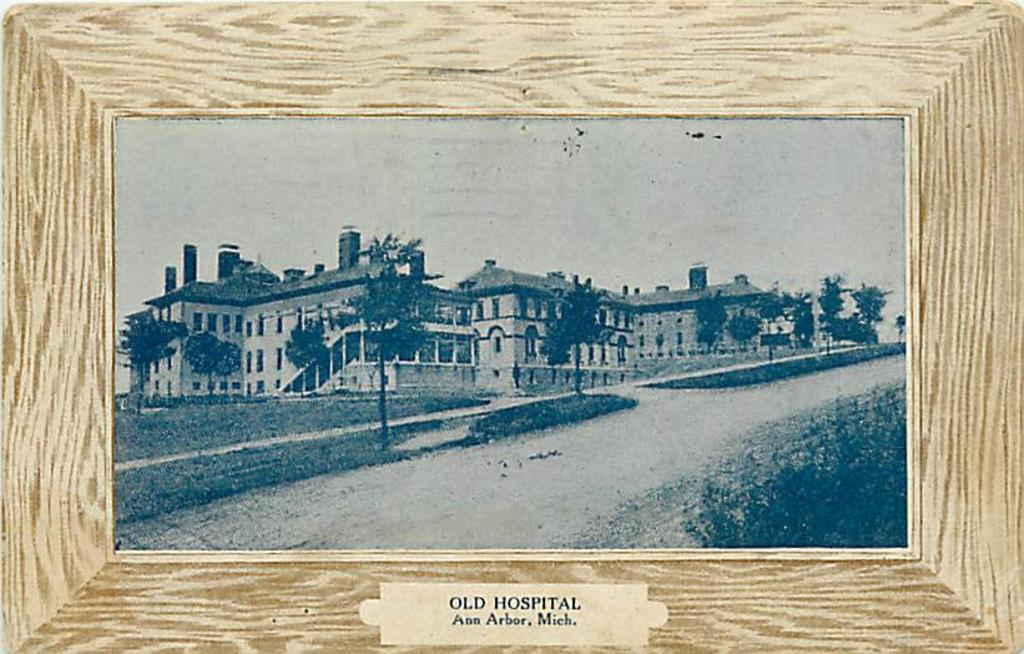What type of object is depicted in the image? The image appears to be a photo frame. What is shown inside the photo frame? There is a picture of a huge palace in the frame. What can be seen in the background of the palace picture? There are many trees around the palace in the picture. Can you tell me how much sand is present around the palace in the image? There is no sand present around the palace in the image; it is surrounded by trees. 